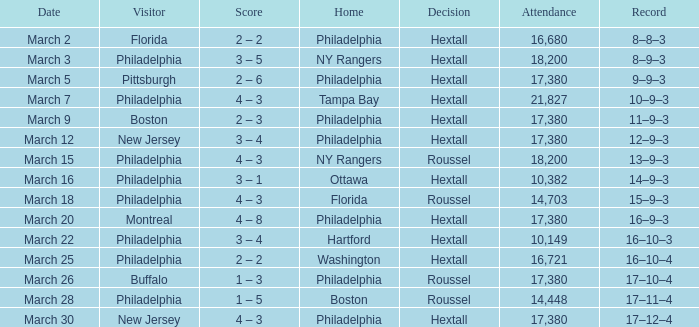Which house is related to the date march 30? Philadelphia. 